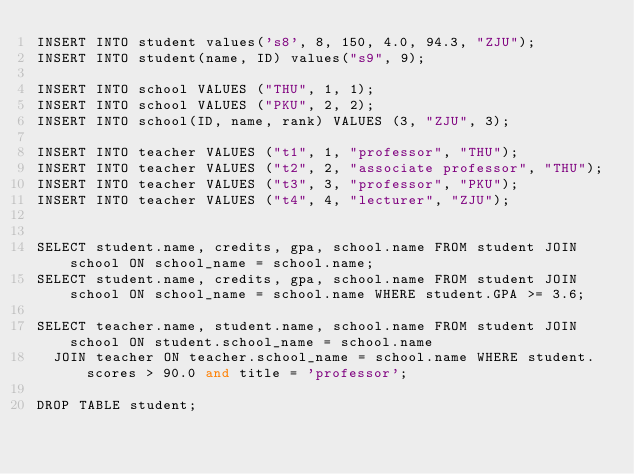<code> <loc_0><loc_0><loc_500><loc_500><_SQL_>INSERT INTO student values('s8', 8, 150, 4.0, 94.3, "ZJU");
INSERT INTO student(name, ID) values("s9", 9);

INSERT INTO school VALUES ("THU", 1, 1);
INSERT INTO school VALUES ("PKU", 2, 2);
INSERT INTO school(ID, name, rank) VALUES (3, "ZJU", 3);

INSERT INTO teacher VALUES ("t1", 1, "professor", "THU");
INSERT INTO teacher VALUES ("t2", 2, "associate professor", "THU");
INSERT INTO teacher VALUES ("t3", 3, "professor", "PKU");
INSERT INTO teacher VALUES ("t4", 4, "lecturer", "ZJU");


SELECT student.name, credits, gpa, school.name FROM student JOIN school ON school_name = school.name;
SELECT student.name, credits, gpa, school.name FROM student JOIN school ON school_name = school.name WHERE student.GPA >= 3.6;

SELECT teacher.name, student.name, school.name FROM student JOIN school ON student.school_name = school.name
  JOIN teacher ON teacher.school_name = school.name WHERE student.scores > 90.0 and title = 'professor';

DROP TABLE student;</code> 